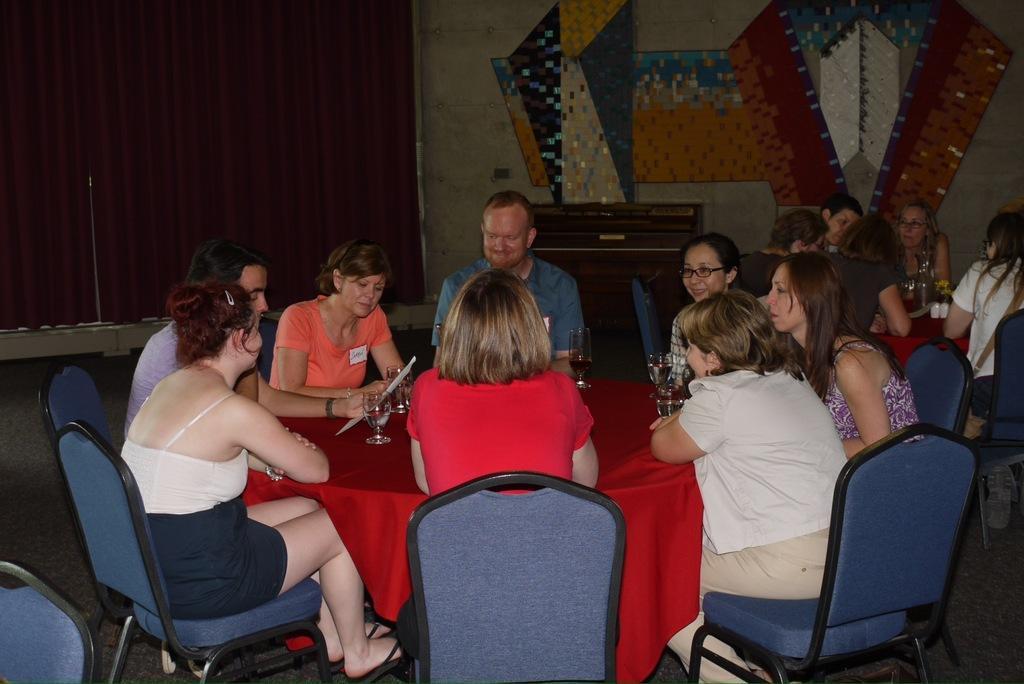Can you describe this image briefly? In this picture there are group of people who are sitting on a chair around the round table. On the table there is glass and a red carpet. In the background there is a curtain and a wall. 